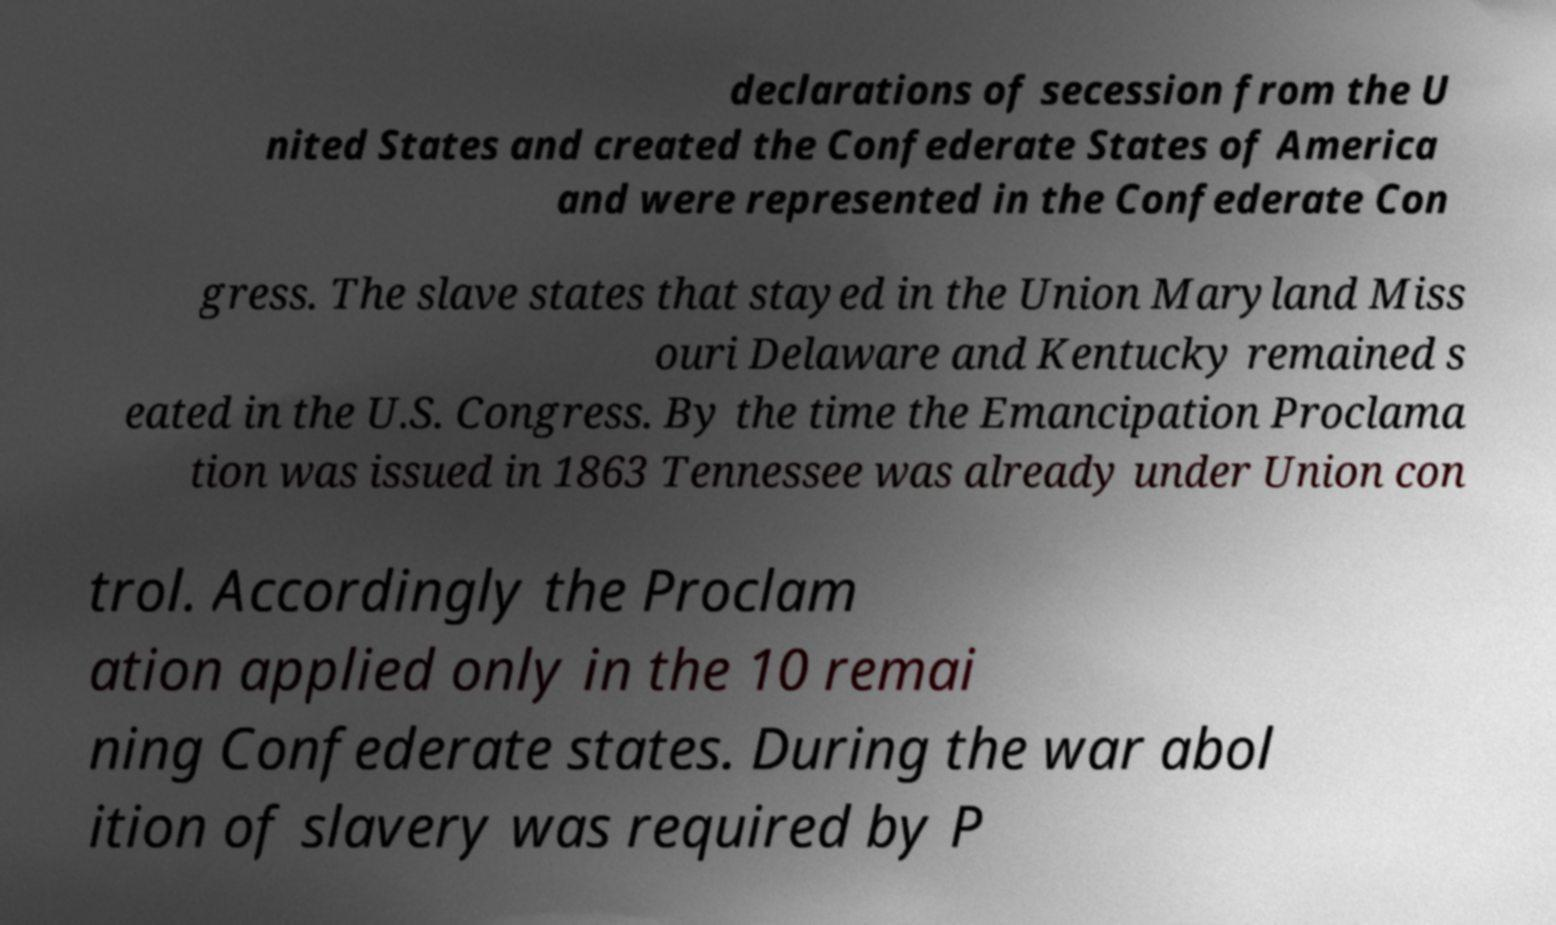Can you read and provide the text displayed in the image?This photo seems to have some interesting text. Can you extract and type it out for me? declarations of secession from the U nited States and created the Confederate States of America and were represented in the Confederate Con gress. The slave states that stayed in the Union Maryland Miss ouri Delaware and Kentucky remained s eated in the U.S. Congress. By the time the Emancipation Proclama tion was issued in 1863 Tennessee was already under Union con trol. Accordingly the Proclam ation applied only in the 10 remai ning Confederate states. During the war abol ition of slavery was required by P 